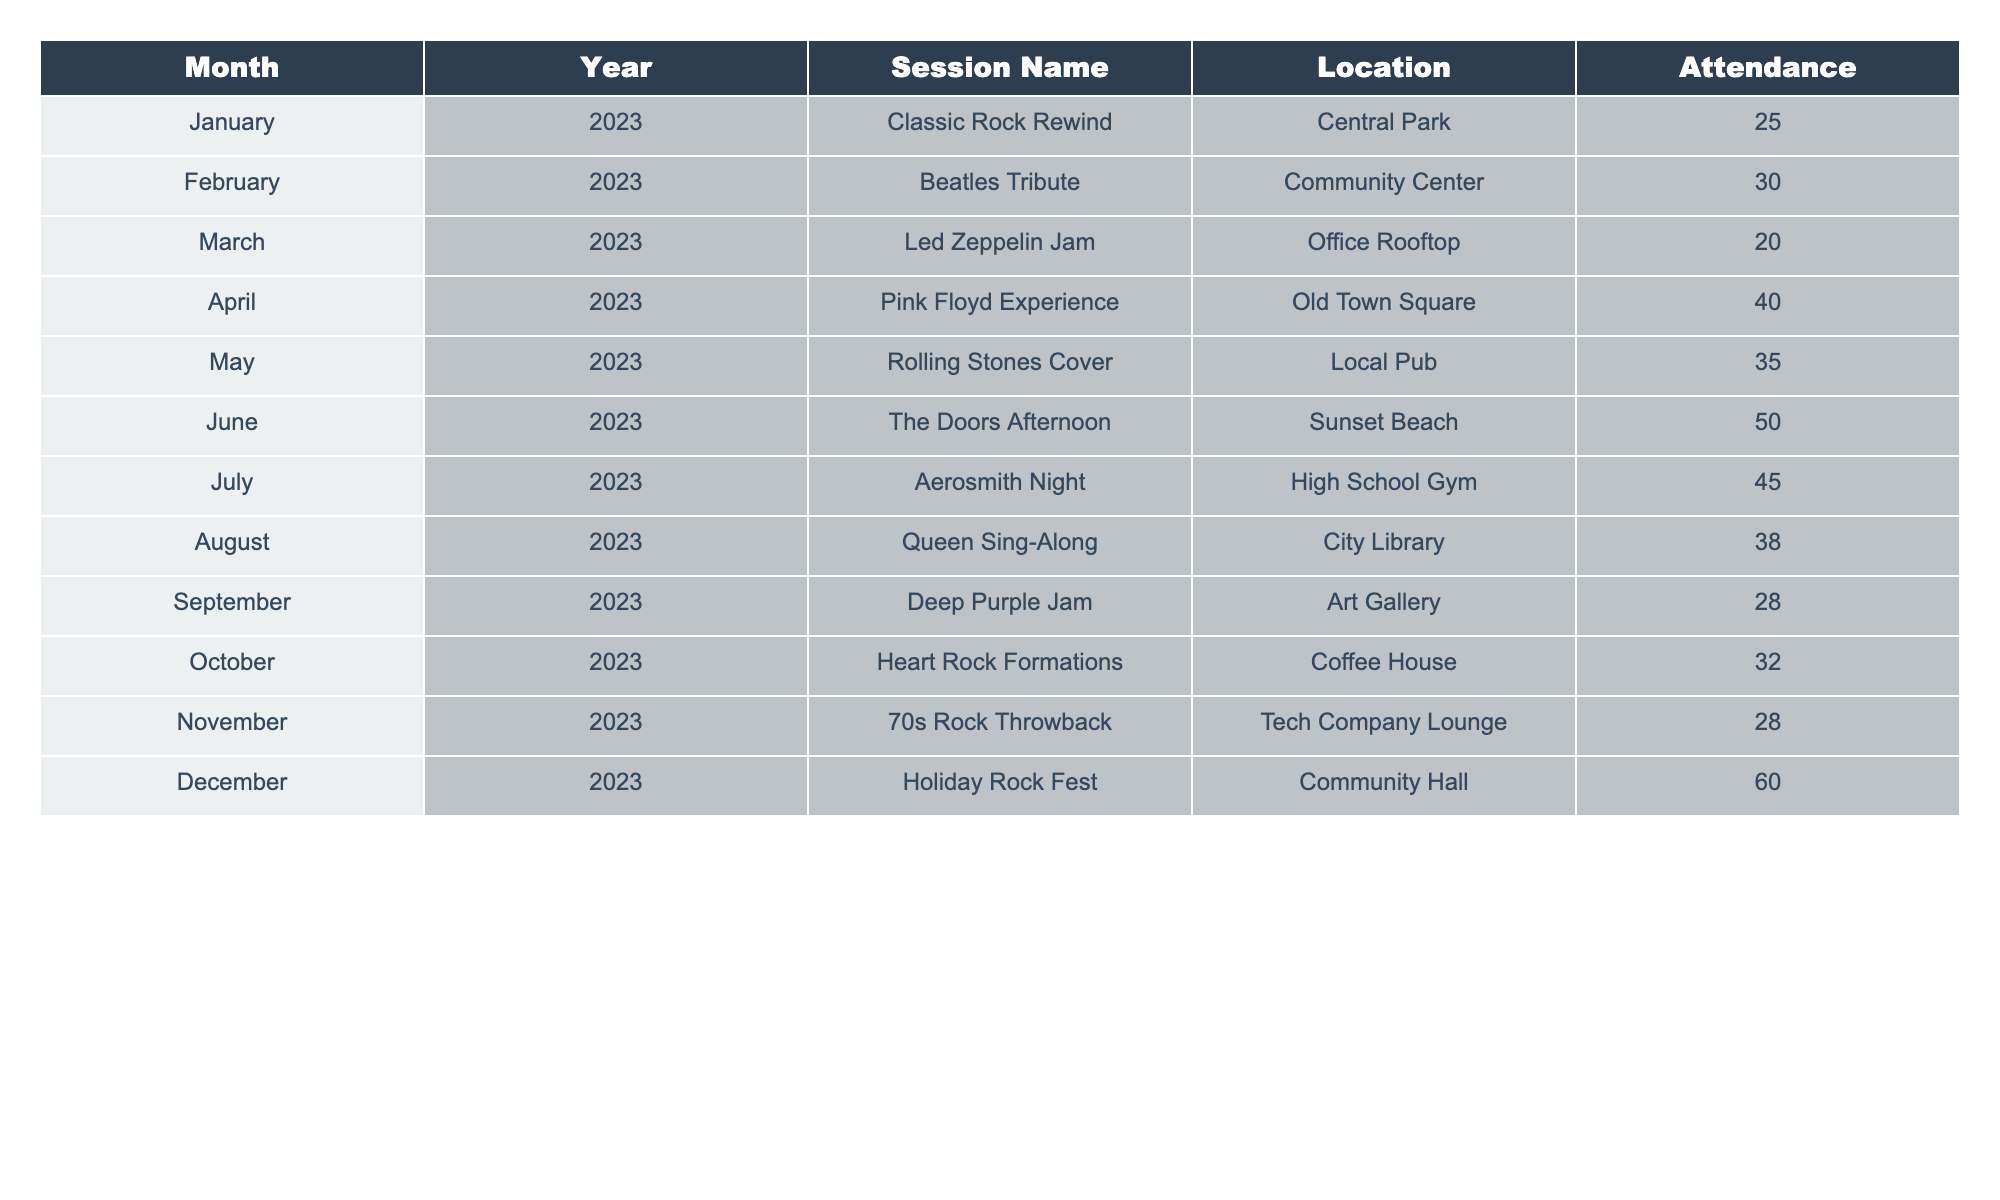What was the highest attendance recorded? Looking at the "Attendance" column, the highest number is 60, which corresponds to the "Holiday Rock Fest" in December 2023.
Answer: 60 In which month did the lowest attendance occur? By scanning through the attendance figures in the table, the lowest recorded attendance is 20, which happened in March 2023 during the "Led Zeppelin Jam."
Answer: March 2023 What is the average attendance for all sessions? Summing up the attendance figures (25 + 30 + 20 + 40 + 35 + 50 + 45 + 38 + 28 + 32 + 28 + 60 =  408) and dividing by the total number of sessions (12) gives an average attendance of 34.
Answer: 34 How many sessions had an attendance of 30 or more? The sessions with an attendance of 30 or more are: Beatles Tribute (30), Pink Floyd Experience (40), Rolling Stones Cover (35), The Doors Afternoon (50), Aerosmith Night (45), Queen Sing-Along (38), October (32), and Holiday Rock Fest (60). That makes it 8 sessions in total.
Answer: 8 Was there a session held in August, and what was its attendance? Checking the table for August, we see the "Queen Sing-Along" was held with an attendance of 38.
Answer: Yes, 38 What is the difference in attendance between the highest and lowest month? The highest attendance (60 in December) minus the lowest attendance (20 in March) gives us a difference of 40.
Answer: 40 Which session had the name reflecting a band from the 70s and what was the attendance? The session "70s Rock Throwback" matches the 70s band theme with an attendance of 28.
Answer: 28 What month has the second highest attendance? The second highest attendance is from July 2023, "Aerosmith Night," which had an attendance of 45, following December's 60.
Answer: July 2023 Calculate the total attendance for the first half of the year (January to June). Adding the attendances for January (25), February (30), March (20), April (40), May (35), and June (50) gives us a total of 200.
Answer: 200 Is there a session in November? If so, what was the name and attendance? Yes, in November there is a session titled "70s Rock Throwback," with an attendance of 28.
Answer: Yes, 28 